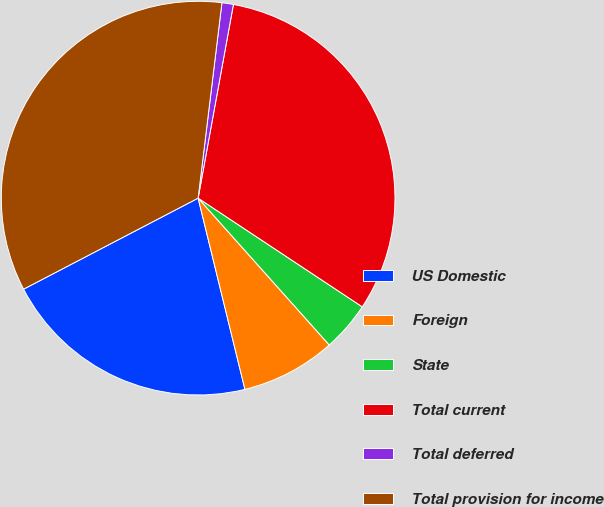<chart> <loc_0><loc_0><loc_500><loc_500><pie_chart><fcel>US Domestic<fcel>Foreign<fcel>State<fcel>Total current<fcel>Total deferred<fcel>Total provision for income<nl><fcel>21.17%<fcel>7.78%<fcel>4.09%<fcel>31.44%<fcel>0.94%<fcel>34.58%<nl></chart> 